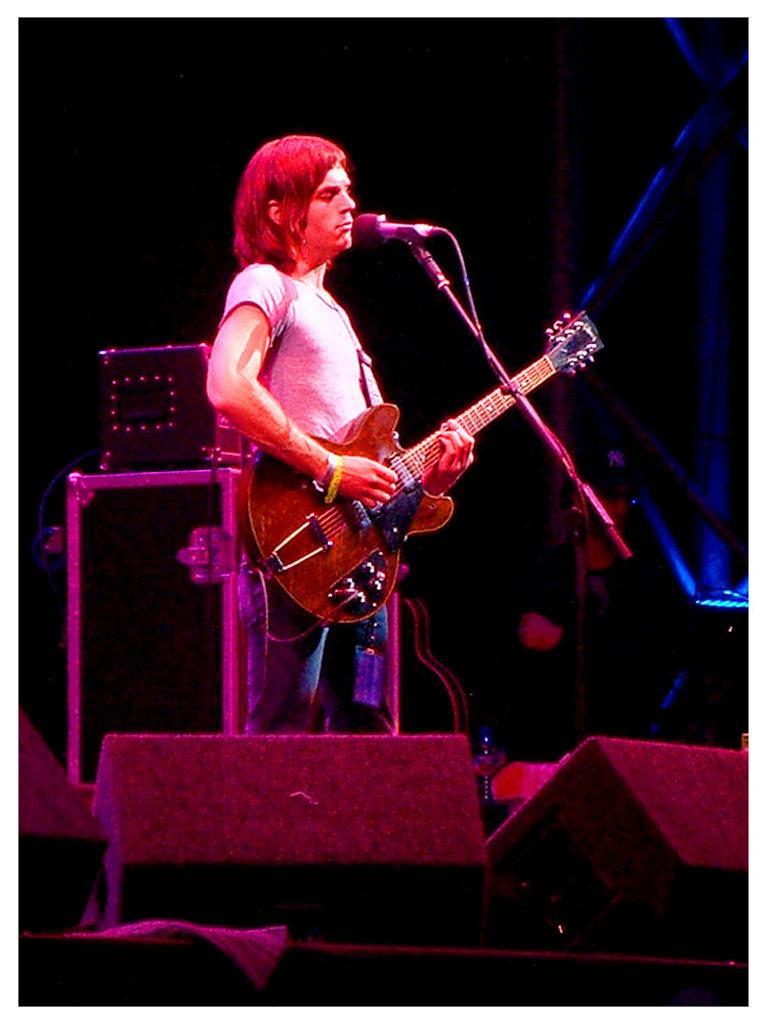Describe this image in one or two sentences. This picture shows a man standing on the stage, holding a guitar and playing it in front of a mic and stand. In the background there are some speakers and a light here. 